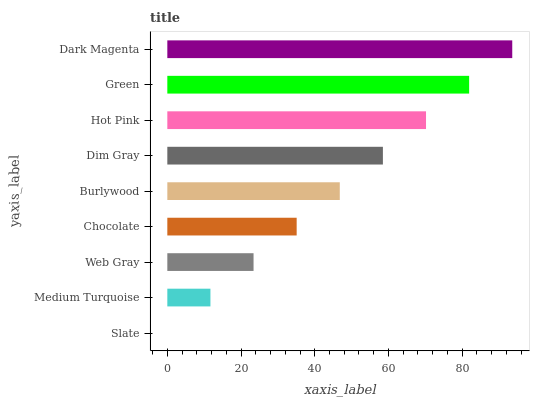Is Slate the minimum?
Answer yes or no. Yes. Is Dark Magenta the maximum?
Answer yes or no. Yes. Is Medium Turquoise the minimum?
Answer yes or no. No. Is Medium Turquoise the maximum?
Answer yes or no. No. Is Medium Turquoise greater than Slate?
Answer yes or no. Yes. Is Slate less than Medium Turquoise?
Answer yes or no. Yes. Is Slate greater than Medium Turquoise?
Answer yes or no. No. Is Medium Turquoise less than Slate?
Answer yes or no. No. Is Burlywood the high median?
Answer yes or no. Yes. Is Burlywood the low median?
Answer yes or no. Yes. Is Medium Turquoise the high median?
Answer yes or no. No. Is Web Gray the low median?
Answer yes or no. No. 